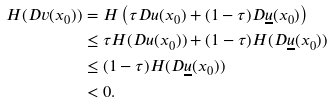Convert formula to latex. <formula><loc_0><loc_0><loc_500><loc_500>H ( D v ( x _ { 0 } ) ) & = H \left ( \tau D u ( x _ { 0 } ) + ( 1 - \tau ) D \underline { u } ( x _ { 0 } ) \right ) \\ & \leq \tau H ( D u ( x _ { 0 } ) ) + ( 1 - \tau ) H ( D \underline { u } ( x _ { 0 } ) ) \\ & \leq ( 1 - \tau ) H ( D \underline { u } ( x _ { 0 } ) ) \\ & < 0 .</formula> 